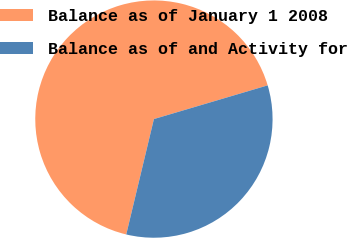Convert chart. <chart><loc_0><loc_0><loc_500><loc_500><pie_chart><fcel>Balance as of January 1 2008<fcel>Balance as of and Activity for<nl><fcel>66.67%<fcel>33.33%<nl></chart> 